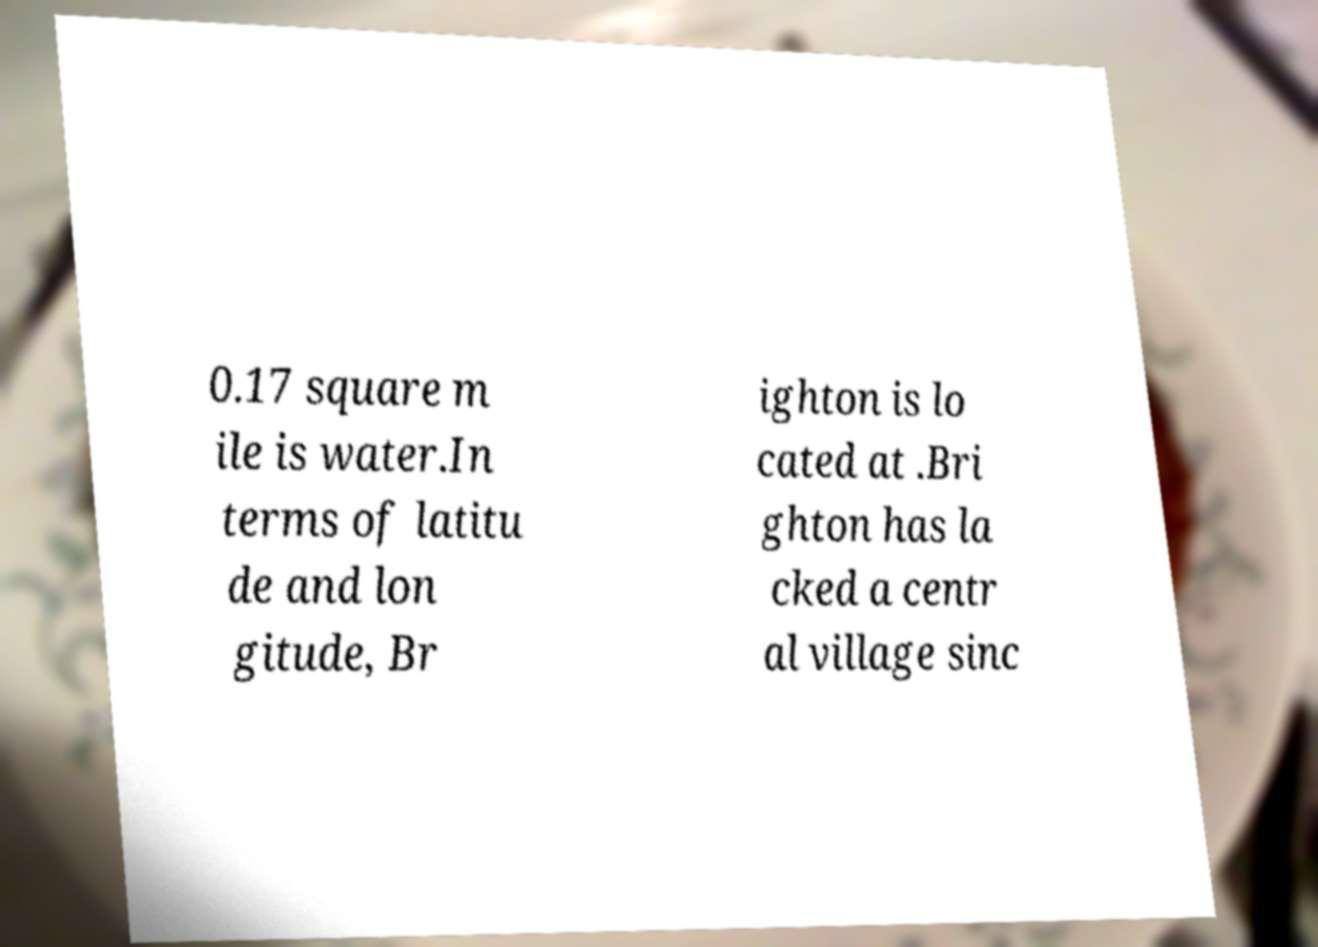Please identify and transcribe the text found in this image. 0.17 square m ile is water.In terms of latitu de and lon gitude, Br ighton is lo cated at .Bri ghton has la cked a centr al village sinc 